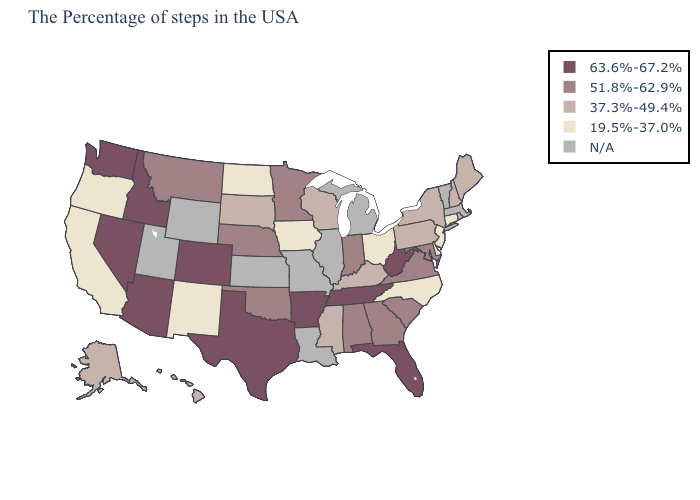Name the states that have a value in the range 19.5%-37.0%?
Keep it brief. Connecticut, New Jersey, Delaware, North Carolina, Ohio, Iowa, North Dakota, New Mexico, California, Oregon. Which states have the lowest value in the MidWest?
Quick response, please. Ohio, Iowa, North Dakota. Among the states that border Georgia , which have the highest value?
Give a very brief answer. Florida, Tennessee. Which states hav the highest value in the South?
Be succinct. West Virginia, Florida, Tennessee, Arkansas, Texas. Name the states that have a value in the range 63.6%-67.2%?
Give a very brief answer. West Virginia, Florida, Tennessee, Arkansas, Texas, Colorado, Arizona, Idaho, Nevada, Washington. What is the highest value in the USA?
Concise answer only. 63.6%-67.2%. Among the states that border Arkansas , does Oklahoma have the highest value?
Quick response, please. No. Which states hav the highest value in the South?
Be succinct. West Virginia, Florida, Tennessee, Arkansas, Texas. How many symbols are there in the legend?
Answer briefly. 5. Among the states that border Arizona , which have the highest value?
Answer briefly. Colorado, Nevada. What is the value of Delaware?
Write a very short answer. 19.5%-37.0%. Name the states that have a value in the range 51.8%-62.9%?
Be succinct. Maryland, Virginia, South Carolina, Georgia, Indiana, Alabama, Minnesota, Nebraska, Oklahoma, Montana. Which states have the highest value in the USA?
Give a very brief answer. West Virginia, Florida, Tennessee, Arkansas, Texas, Colorado, Arizona, Idaho, Nevada, Washington. 